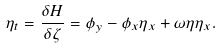Convert formula to latex. <formula><loc_0><loc_0><loc_500><loc_500>\eta _ { t } = \frac { \delta H } { \delta \zeta } = \phi _ { y } - \phi _ { x } \eta _ { x } + \omega \eta \eta _ { x } .</formula> 